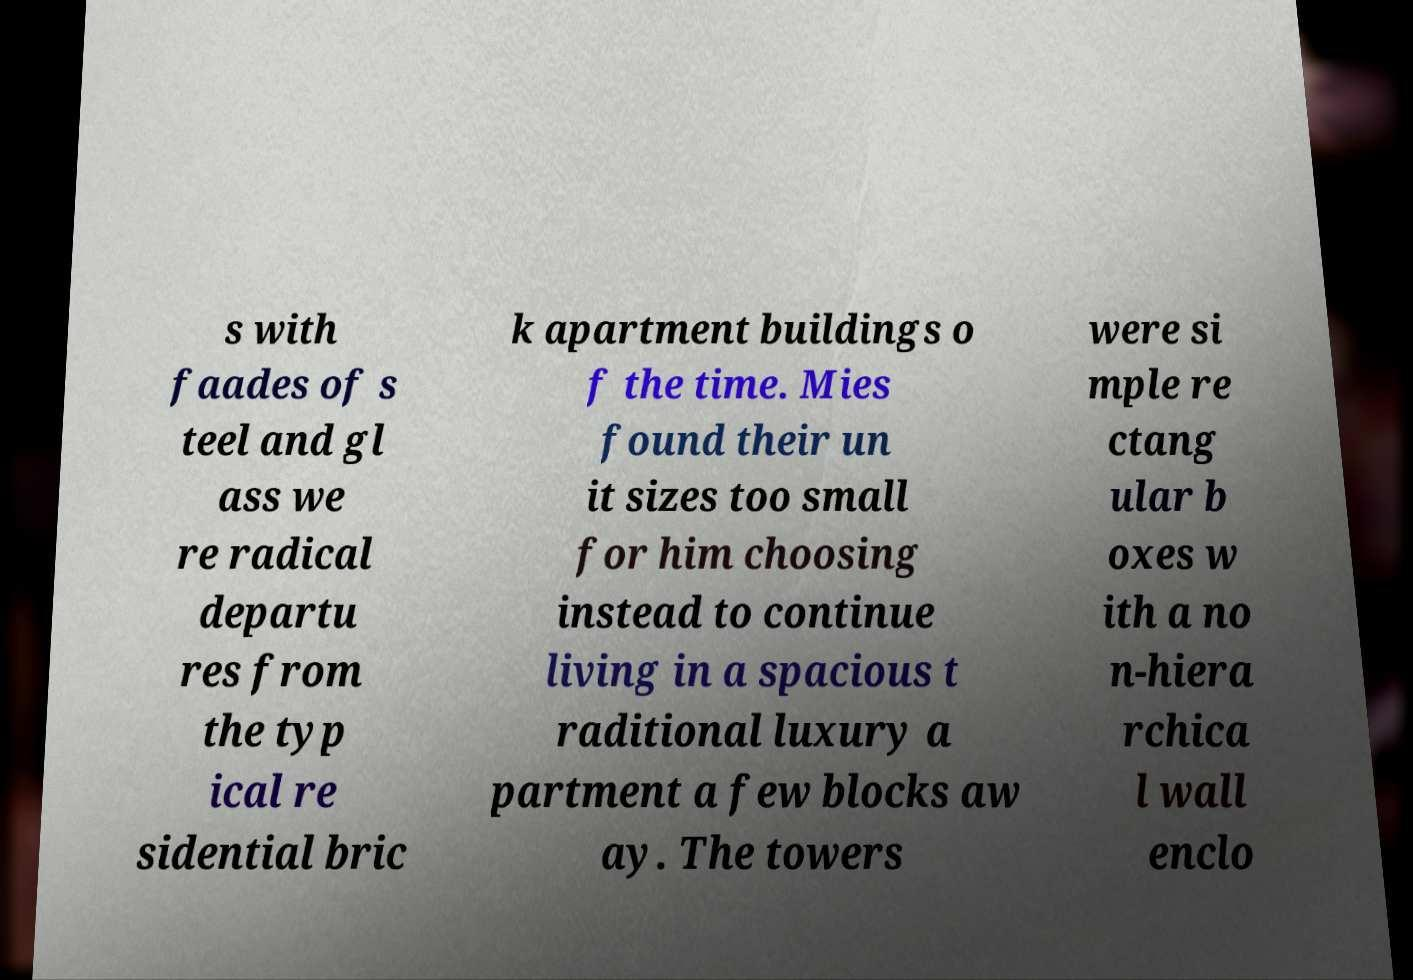What messages or text are displayed in this image? I need them in a readable, typed format. s with faades of s teel and gl ass we re radical departu res from the typ ical re sidential bric k apartment buildings o f the time. Mies found their un it sizes too small for him choosing instead to continue living in a spacious t raditional luxury a partment a few blocks aw ay. The towers were si mple re ctang ular b oxes w ith a no n-hiera rchica l wall enclo 